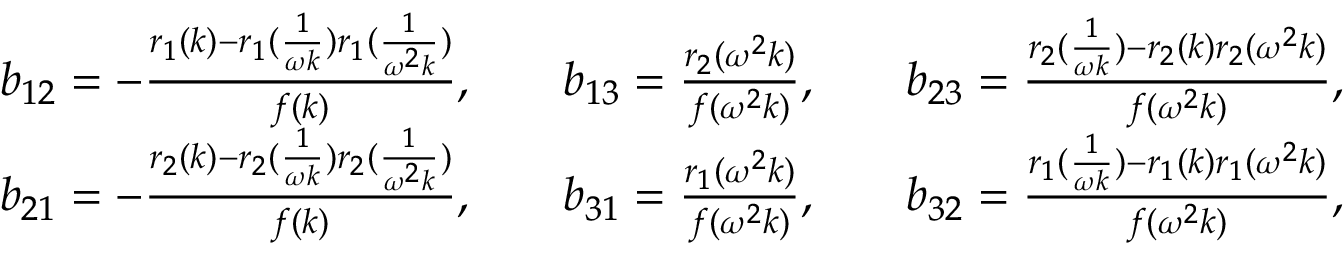<formula> <loc_0><loc_0><loc_500><loc_500>\begin{array} { r l r l r l } & { b _ { 1 2 } = - \frac { r _ { 1 } ( k ) - r _ { 1 } ( \frac { 1 } { \omega k } ) r _ { 1 } ( \frac { 1 } { \omega ^ { 2 } k } ) } { f ( k ) } , } & & { b _ { 1 3 } = \frac { r _ { 2 } ( \omega ^ { 2 } k ) } { f ( \omega ^ { 2 } k ) } , } & & { b _ { 2 3 } = \frac { r _ { 2 } ( \frac { 1 } { \omega k } ) - r _ { 2 } ( k ) r _ { 2 } ( \omega ^ { 2 } k ) } { f ( \omega ^ { 2 } k ) } , } \\ & { b _ { 2 1 } = - \frac { r _ { 2 } ( k ) - r _ { 2 } ( \frac { 1 } { \omega k } ) r _ { 2 } ( \frac { 1 } { \omega ^ { 2 } k } ) } { f ( k ) } , } & & { b _ { 3 1 } = \frac { r _ { 1 } ( \omega ^ { 2 } k ) } { f ( \omega ^ { 2 } k ) } , } & & { b _ { 3 2 } = \frac { r _ { 1 } ( \frac { 1 } { \omega k } ) - r _ { 1 } ( k ) r _ { 1 } ( \omega ^ { 2 } k ) } { f ( \omega ^ { 2 } k ) } , } \end{array}</formula> 